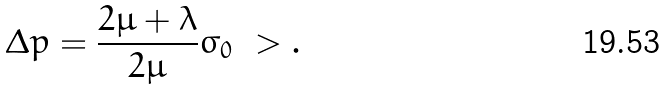<formula> <loc_0><loc_0><loc_500><loc_500>\Delta p = \frac { 2 \mu + \lambda } { 2 \mu } \sigma _ { 0 } \ > .</formula> 